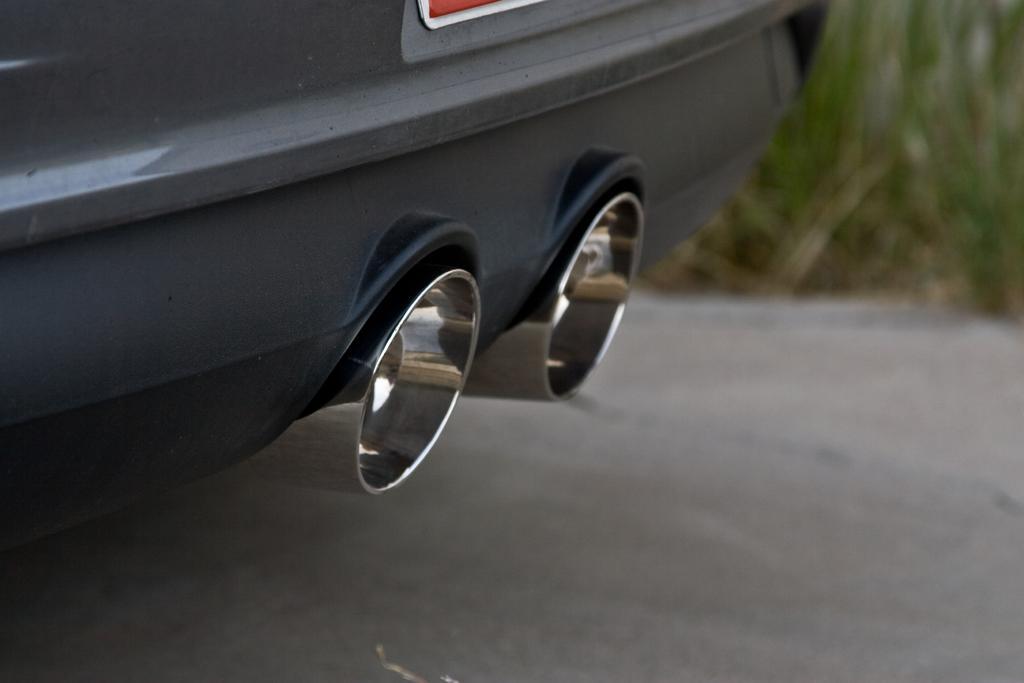In one or two sentences, can you explain what this image depicts? In this picture I can observe tailpipes of a vehicle. The background is blurred. 